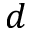Convert formula to latex. <formula><loc_0><loc_0><loc_500><loc_500>d</formula> 